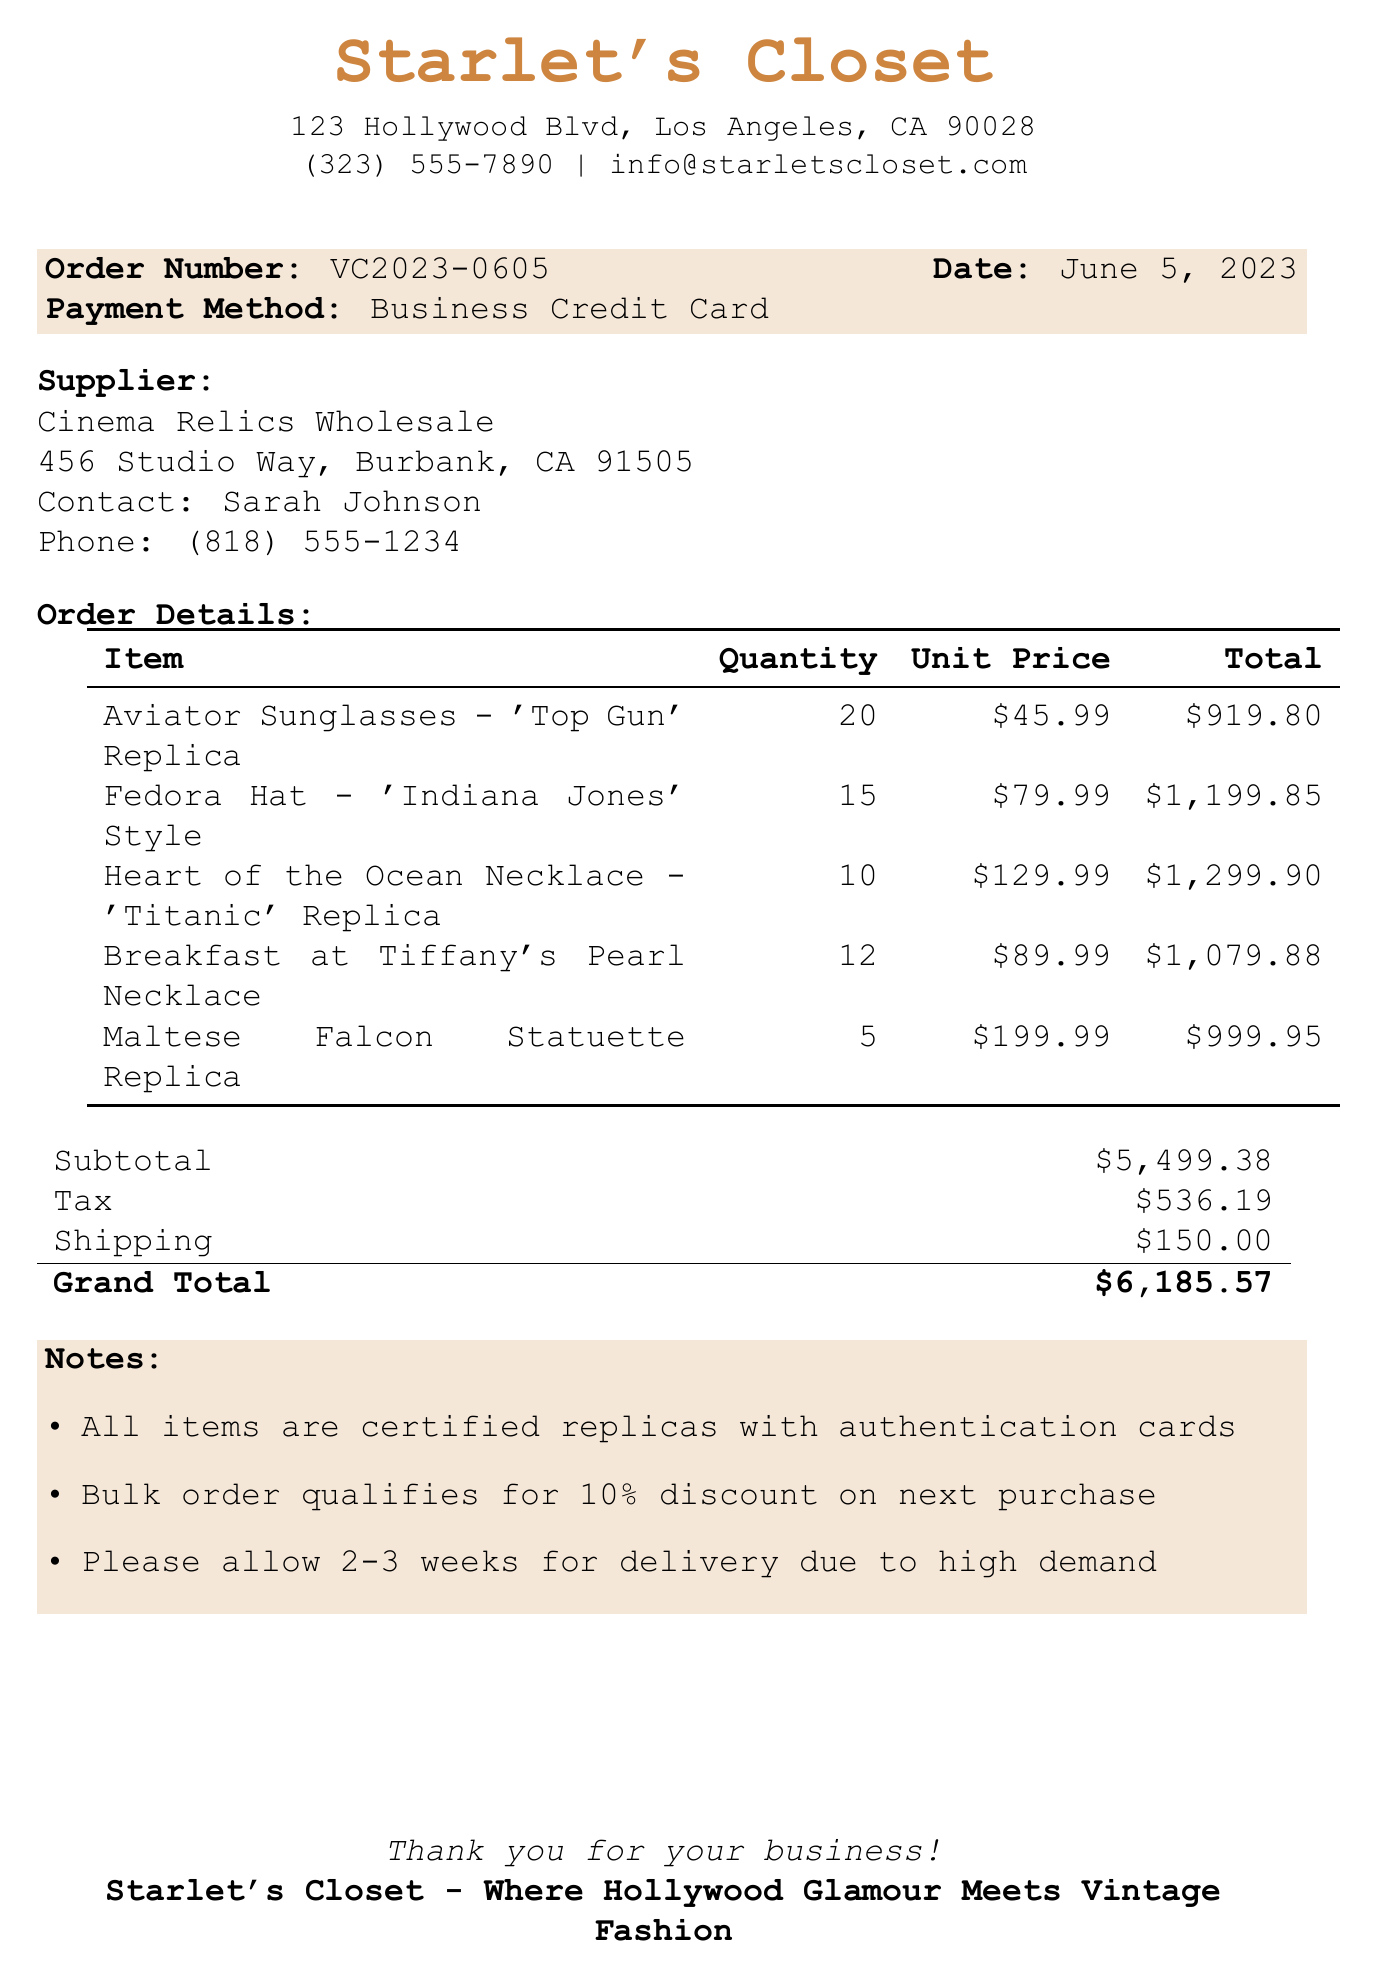What is the order number? The order number is explicitly stated in the document for reference.
Answer: VC2023-0605 Who is the contact person at the supplier? The document lists the contact person associated with the supplier for direct communication.
Answer: Sarah Johnson What is the payment method used for this order? The payment method is noted in the order details section of the receipt.
Answer: Business Credit Card How many units of the Heart of the Ocean Necklace were ordered? The quantity of this specific item ordered is provided in the item list.
Answer: 10 What is the subtotal of the order? The subtotal is clearly listed in the totals section of the document.
Answer: $5,499.38 Which item qualifies for a discount on the next purchase? The notes section mentions conditions that apply to the bulk order.
Answer: All items What is the shipping cost? The overall shipping fee can be found in the totals area of the receipt.
Answer: $150.00 When was the order placed? The date of the order is specified prominently in the order details.
Answer: June 5, 2023 How long should delivery take? The estimated delivery time is mentioned in the notes section of the document.
Answer: 2-3 weeks 